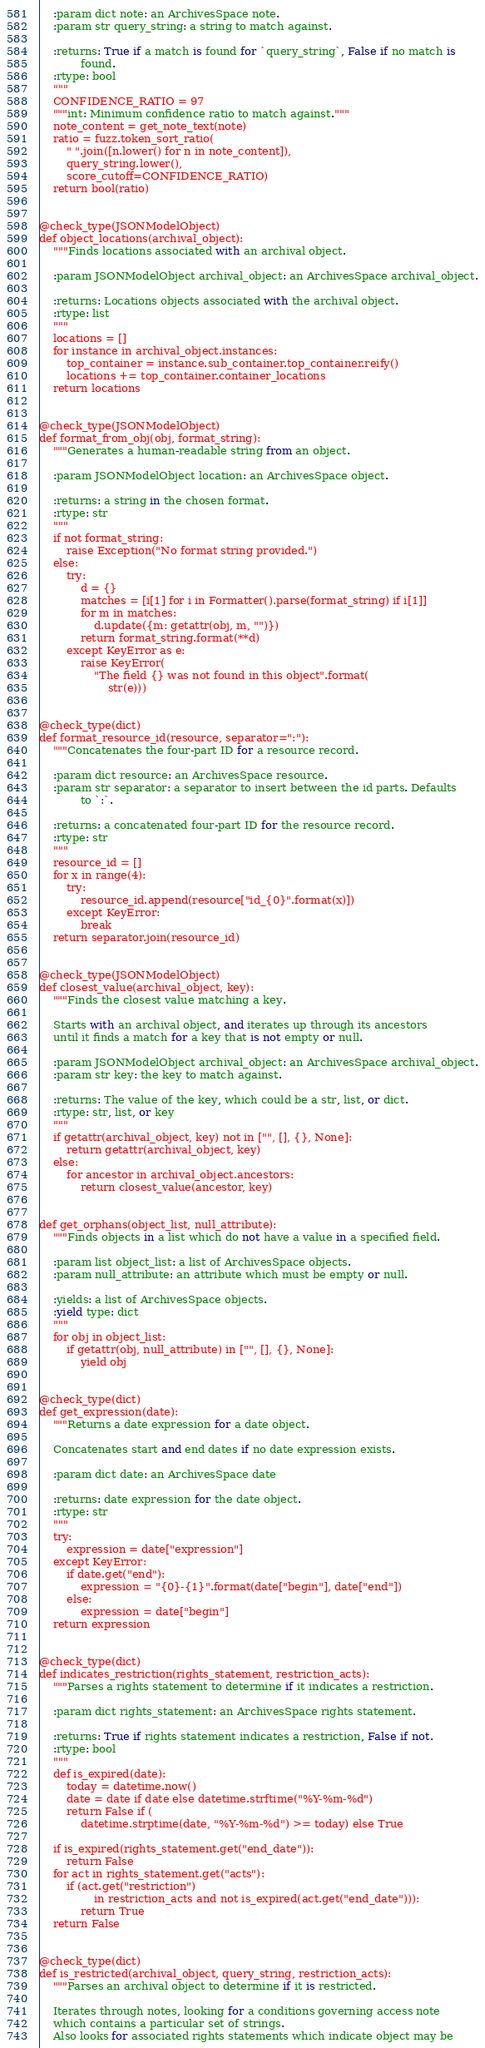<code> <loc_0><loc_0><loc_500><loc_500><_Python_>    :param dict note: an ArchivesSpace note.
    :param str query_string: a string to match against.

    :returns: True if a match is found for `query_string`, False if no match is
            found.
    :rtype: bool
    """
    CONFIDENCE_RATIO = 97
    """int: Minimum confidence ratio to match against."""
    note_content = get_note_text(note)
    ratio = fuzz.token_sort_ratio(
        " ".join([n.lower() for n in note_content]),
        query_string.lower(),
        score_cutoff=CONFIDENCE_RATIO)
    return bool(ratio)


@check_type(JSONModelObject)
def object_locations(archival_object):
    """Finds locations associated with an archival object.

    :param JSONModelObject archival_object: an ArchivesSpace archival_object.

    :returns: Locations objects associated with the archival object.
    :rtype: list
    """
    locations = []
    for instance in archival_object.instances:
        top_container = instance.sub_container.top_container.reify()
        locations += top_container.container_locations
    return locations


@check_type(JSONModelObject)
def format_from_obj(obj, format_string):
    """Generates a human-readable string from an object.

    :param JSONModelObject location: an ArchivesSpace object.

    :returns: a string in the chosen format.
    :rtype: str
    """
    if not format_string:
        raise Exception("No format string provided.")
    else:
        try:
            d = {}
            matches = [i[1] for i in Formatter().parse(format_string) if i[1]]
            for m in matches:
                d.update({m: getattr(obj, m, "")})
            return format_string.format(**d)
        except KeyError as e:
            raise KeyError(
                "The field {} was not found in this object".format(
                    str(e)))


@check_type(dict)
def format_resource_id(resource, separator=":"):
    """Concatenates the four-part ID for a resource record.

    :param dict resource: an ArchivesSpace resource.
    :param str separator: a separator to insert between the id parts. Defaults
            to `:`.

    :returns: a concatenated four-part ID for the resource record.
    :rtype: str
    """
    resource_id = []
    for x in range(4):
        try:
            resource_id.append(resource["id_{0}".format(x)])
        except KeyError:
            break
    return separator.join(resource_id)


@check_type(JSONModelObject)
def closest_value(archival_object, key):
    """Finds the closest value matching a key.

    Starts with an archival object, and iterates up through its ancestors
    until it finds a match for a key that is not empty or null.

    :param JSONModelObject archival_object: an ArchivesSpace archival_object.
    :param str key: the key to match against.

    :returns: The value of the key, which could be a str, list, or dict.
    :rtype: str, list, or key
    """
    if getattr(archival_object, key) not in ["", [], {}, None]:
        return getattr(archival_object, key)
    else:
        for ancestor in archival_object.ancestors:
            return closest_value(ancestor, key)


def get_orphans(object_list, null_attribute):
    """Finds objects in a list which do not have a value in a specified field.

    :param list object_list: a list of ArchivesSpace objects.
    :param null_attribute: an attribute which must be empty or null.

    :yields: a list of ArchivesSpace objects.
    :yield type: dict
    """
    for obj in object_list:
        if getattr(obj, null_attribute) in ["", [], {}, None]:
            yield obj


@check_type(dict)
def get_expression(date):
    """Returns a date expression for a date object.

    Concatenates start and end dates if no date expression exists.

    :param dict date: an ArchivesSpace date

    :returns: date expression for the date object.
    :rtype: str
    """
    try:
        expression = date["expression"]
    except KeyError:
        if date.get("end"):
            expression = "{0}-{1}".format(date["begin"], date["end"])
        else:
            expression = date["begin"]
    return expression


@check_type(dict)
def indicates_restriction(rights_statement, restriction_acts):
    """Parses a rights statement to determine if it indicates a restriction.

    :param dict rights_statement: an ArchivesSpace rights statement.

    :returns: True if rights statement indicates a restriction, False if not.
    :rtype: bool
    """
    def is_expired(date):
        today = datetime.now()
        date = date if date else datetime.strftime("%Y-%m-%d")
        return False if (
            datetime.strptime(date, "%Y-%m-%d") >= today) else True

    if is_expired(rights_statement.get("end_date")):
        return False
    for act in rights_statement.get("acts"):
        if (act.get("restriction")
                in restriction_acts and not is_expired(act.get("end_date"))):
            return True
    return False


@check_type(dict)
def is_restricted(archival_object, query_string, restriction_acts):
    """Parses an archival object to determine if it is restricted.

    Iterates through notes, looking for a conditions governing access note
    which contains a particular set of strings.
    Also looks for associated rights statements which indicate object may be</code> 